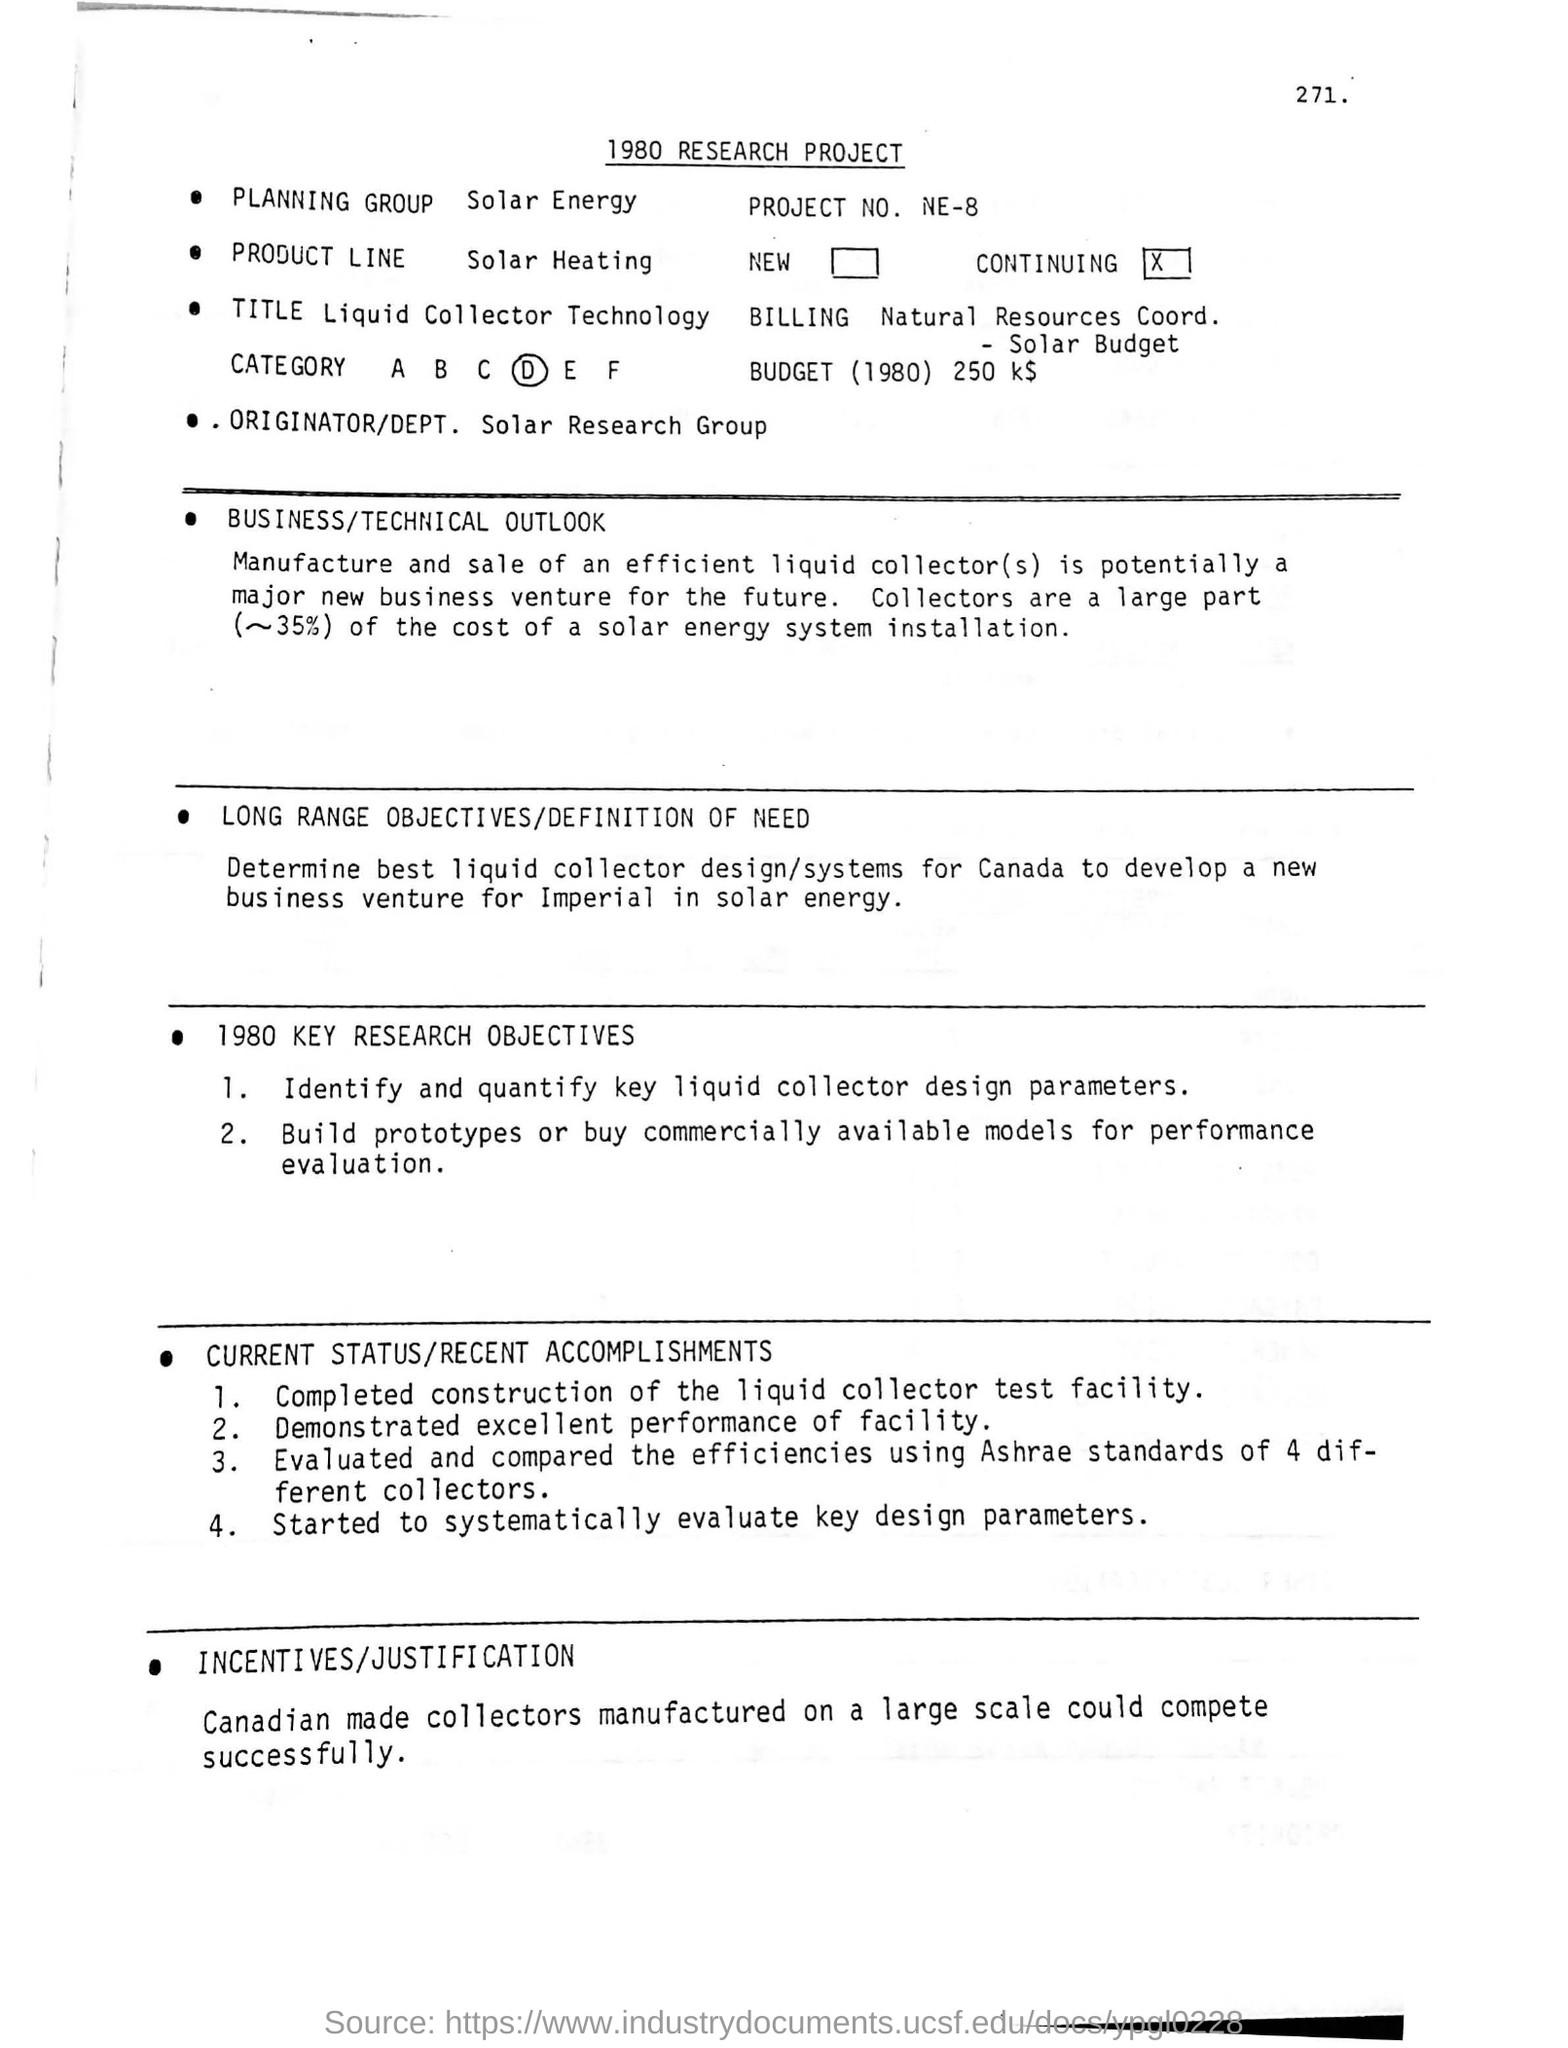Identify some key points in this picture. The best liquid collector design/systems for a particular country have been determined to be Canada. The standard used to evaluate and compare the efficiencies of four different collectors is the Ashrae. Canadian-made collectors that are manufactured on a large scale have the potential to successfully compete in the market. The heading of the document, written at the top of the document, is a 1980 research project. The majority of the expenses associated with installing a solar energy system are collectors. 